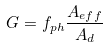<formula> <loc_0><loc_0><loc_500><loc_500>G = f _ { p h } \frac { A _ { e f f } } { A _ { d } }</formula> 